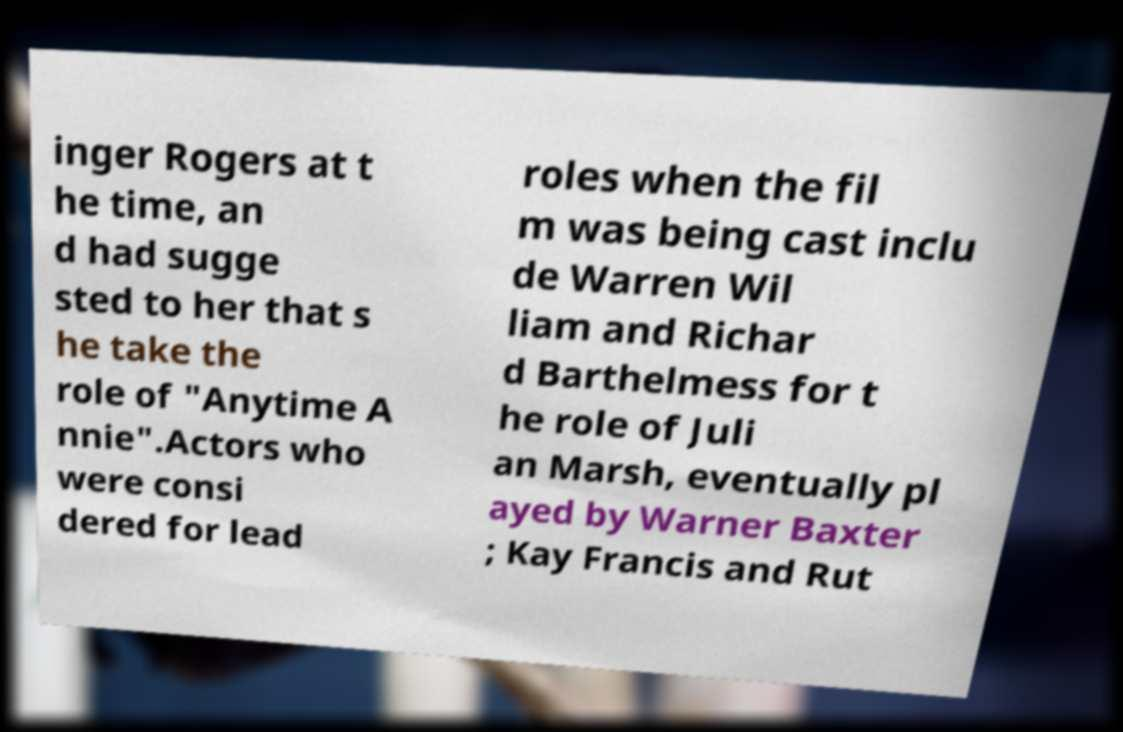I need the written content from this picture converted into text. Can you do that? inger Rogers at t he time, an d had sugge sted to her that s he take the role of "Anytime A nnie".Actors who were consi dered for lead roles when the fil m was being cast inclu de Warren Wil liam and Richar d Barthelmess for t he role of Juli an Marsh, eventually pl ayed by Warner Baxter ; Kay Francis and Rut 